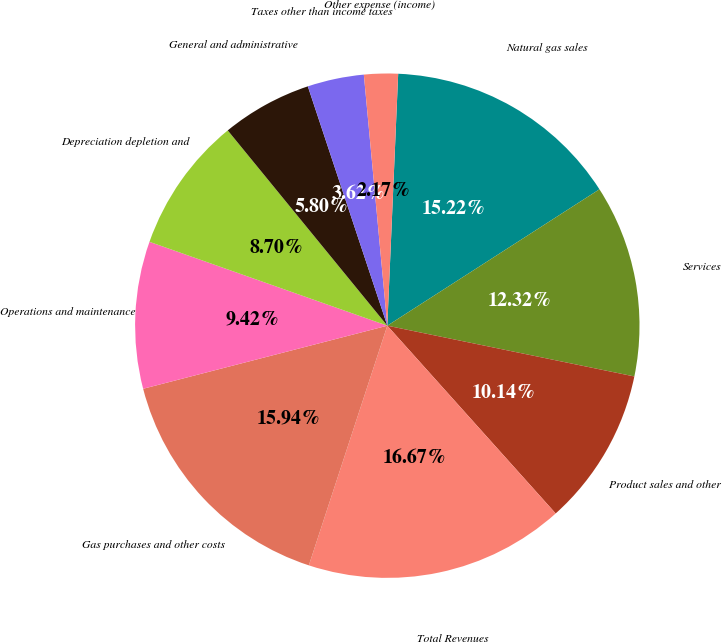Convert chart to OTSL. <chart><loc_0><loc_0><loc_500><loc_500><pie_chart><fcel>Natural gas sales<fcel>Services<fcel>Product sales and other<fcel>Total Revenues<fcel>Gas purchases and other costs<fcel>Operations and maintenance<fcel>Depreciation depletion and<fcel>General and administrative<fcel>Taxes other than income taxes<fcel>Other expense (income)<nl><fcel>15.22%<fcel>12.32%<fcel>10.14%<fcel>16.67%<fcel>15.94%<fcel>9.42%<fcel>8.7%<fcel>5.8%<fcel>3.62%<fcel>2.17%<nl></chart> 